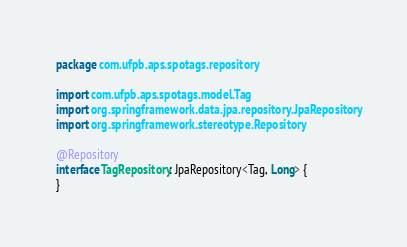<code> <loc_0><loc_0><loc_500><loc_500><_Kotlin_>package com.ufpb.aps.spotags.repository

import com.ufpb.aps.spotags.model.Tag
import org.springframework.data.jpa.repository.JpaRepository
import org.springframework.stereotype.Repository

@Repository
interface TagRepository: JpaRepository<Tag, Long> {
}</code> 